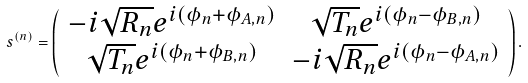Convert formula to latex. <formula><loc_0><loc_0><loc_500><loc_500>s ^ { ( n ) } = \left ( \begin{array} { c c } - i \sqrt { R _ { n } } e ^ { i ( \phi _ { n } + \phi _ { A , n } ) } & \sqrt { T _ { n } } e ^ { i ( \phi _ { n } - \phi _ { B , n } ) } \\ \sqrt { T _ { n } } e ^ { i ( \phi _ { n } + \phi _ { B , n } ) } & - i \sqrt { R _ { n } } e ^ { i ( \phi _ { n } - \phi _ { A , n } ) } \\ \end{array} \right ) .</formula> 